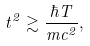Convert formula to latex. <formula><loc_0><loc_0><loc_500><loc_500>t ^ { 2 } \gtrsim \frac { \hbar { T } } { m c ^ { 2 } } ,</formula> 